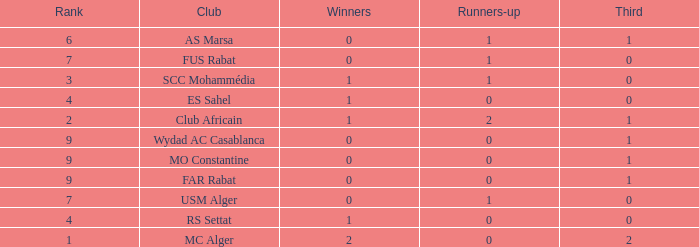Which Third has Runners-up of 0, and Winners of 0, and a Club of far rabat? 1.0. 